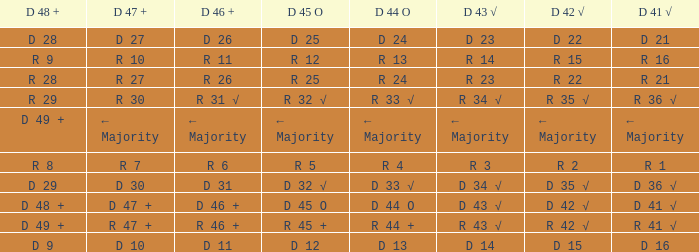What is the value of D 43 √ when the value of D 42 √ is d 42 √? D 43 √. 